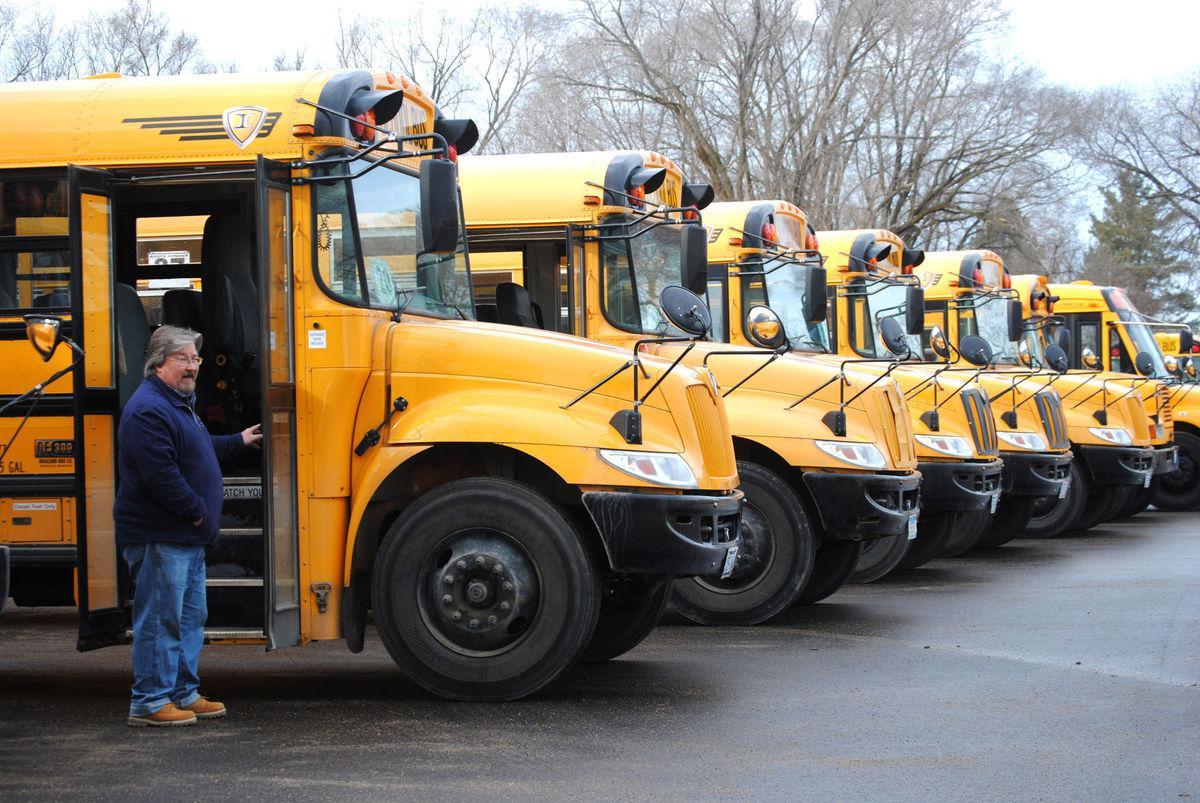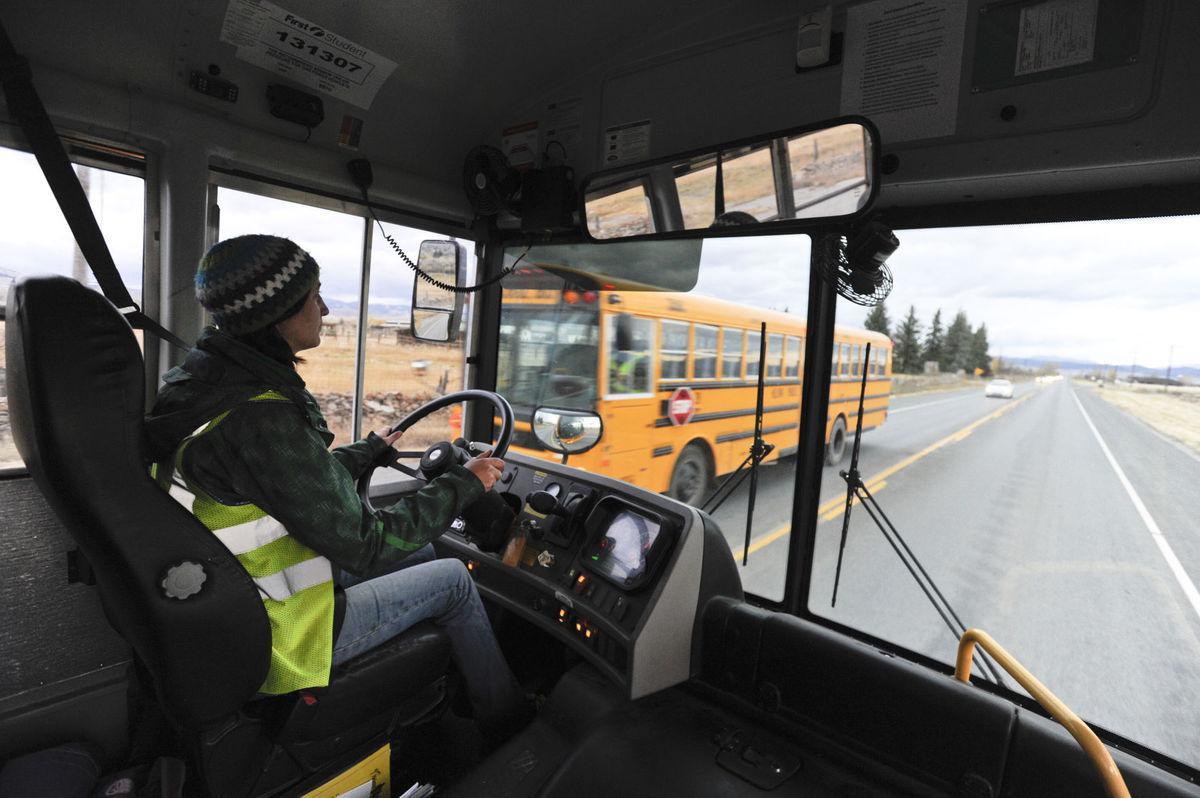The first image is the image on the left, the second image is the image on the right. For the images shown, is this caption "One image shows schoolbuses parked next to each other facing rightward." true? Answer yes or no. Yes. The first image is the image on the left, the second image is the image on the right. Analyze the images presented: Is the assertion "In the left image, one person is in front of the open side-entry passenger door of a bus." valid? Answer yes or no. Yes. 